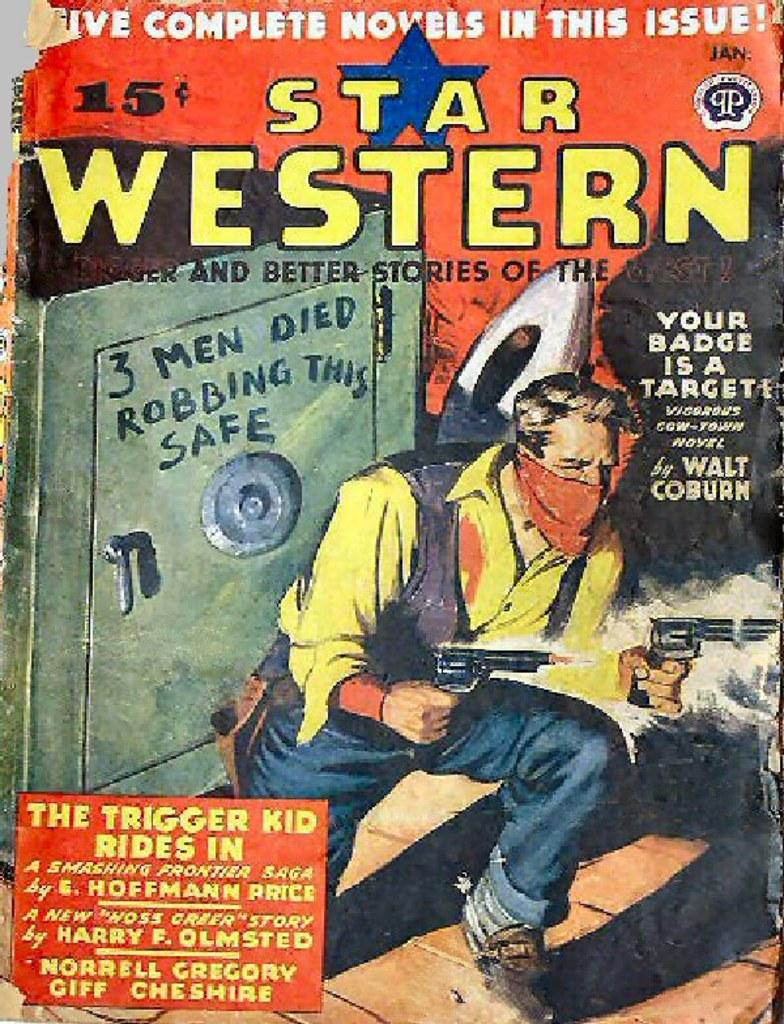<image>
Summarize the visual content of the image. A book with Five Complete Novels in This Issue. 